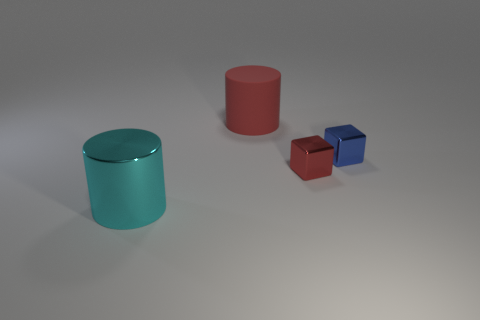What is the size of the metallic thing that is the same color as the rubber thing?
Your answer should be very brief. Small. Are any big shiny cylinders visible?
Your answer should be compact. Yes. The big object behind the tiny blue block to the right of the red cube is what color?
Keep it short and to the point. Red. There is another thing that is the same shape as the tiny red shiny object; what is its material?
Your response must be concise. Metal. How many other red metallic blocks are the same size as the red metallic block?
Ensure brevity in your answer.  0. There is a cyan object that is the same material as the tiny blue block; what is its size?
Give a very brief answer. Large. How many tiny blue metal things have the same shape as the small red metal object?
Give a very brief answer. 1. How many tiny blue metallic objects are there?
Provide a short and direct response. 1. There is a blue metallic object behind the small red cube; does it have the same shape as the matte object?
Your answer should be compact. No. There is a red thing that is the same size as the cyan object; what is it made of?
Give a very brief answer. Rubber. 